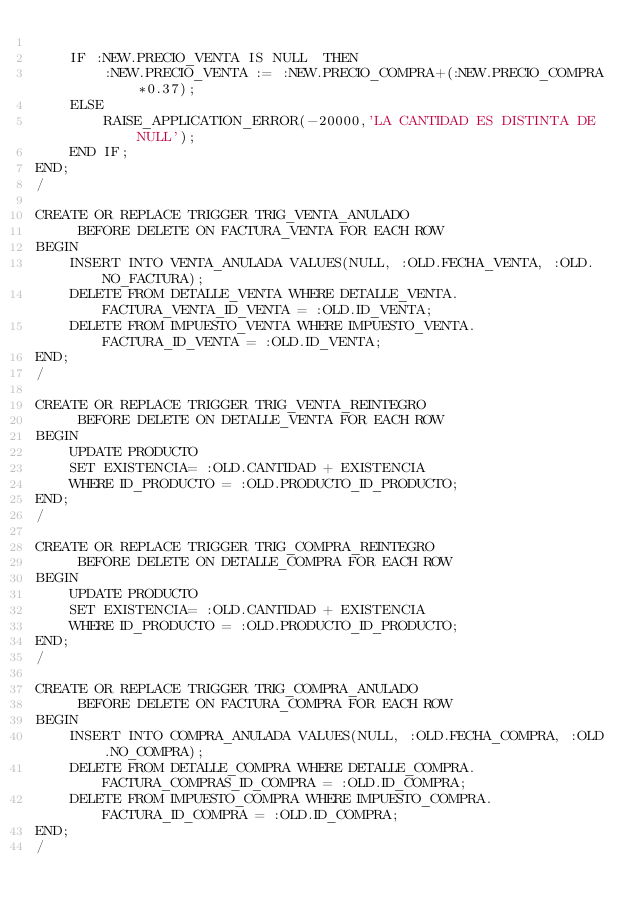Convert code to text. <code><loc_0><loc_0><loc_500><loc_500><_SQL_>
    IF :NEW.PRECIO_VENTA IS NULL  THEN
        :NEW.PRECIO_VENTA := :NEW.PRECIO_COMPRA+(:NEW.PRECIO_COMPRA*0.37); 
    ELSE 
        RAISE_APPLICATION_ERROR(-20000,'LA CANTIDAD ES DISTINTA DE NULL');
    END IF;
END;
/

CREATE OR REPLACE TRIGGER TRIG_VENTA_ANULADO
     BEFORE DELETE ON FACTURA_VENTA FOR EACH ROW
BEGIN
    INSERT INTO VENTA_ANULADA VALUES(NULL, :OLD.FECHA_VENTA, :OLD.NO_FACTURA);
    DELETE FROM DETALLE_VENTA WHERE DETALLE_VENTA.FACTURA_VENTA_ID_VENTA = :OLD.ID_VENTA;
    DELETE FROM IMPUESTO_VENTA WHERE IMPUESTO_VENTA.FACTURA_ID_VENTA = :OLD.ID_VENTA;
END;
/

CREATE OR REPLACE TRIGGER TRIG_VENTA_REINTEGRO
     BEFORE DELETE ON DETALLE_VENTA FOR EACH ROW
BEGIN
    UPDATE PRODUCTO
    SET EXISTENCIA= :OLD.CANTIDAD + EXISTENCIA
    WHERE ID_PRODUCTO = :OLD.PRODUCTO_ID_PRODUCTO;
END;
/

CREATE OR REPLACE TRIGGER TRIG_COMPRA_REINTEGRO
     BEFORE DELETE ON DETALLE_COMPRA FOR EACH ROW
BEGIN
    UPDATE PRODUCTO
    SET EXISTENCIA= :OLD.CANTIDAD + EXISTENCIA
    WHERE ID_PRODUCTO = :OLD.PRODUCTO_ID_PRODUCTO;
END;
/

CREATE OR REPLACE TRIGGER TRIG_COMPRA_ANULADO
     BEFORE DELETE ON FACTURA_COMPRA FOR EACH ROW
BEGIN
    INSERT INTO COMPRA_ANULADA VALUES(NULL, :OLD.FECHA_COMPRA, :OLD.NO_COMPRA);
    DELETE FROM DETALLE_COMPRA WHERE DETALLE_COMPRA.FACTURA_COMPRAS_ID_COMPRA = :OLD.ID_COMPRA;
    DELETE FROM IMPUESTO_COMPRA WHERE IMPUESTO_COMPRA.FACTURA_ID_COMPRA = :OLD.ID_COMPRA;
END;
/</code> 